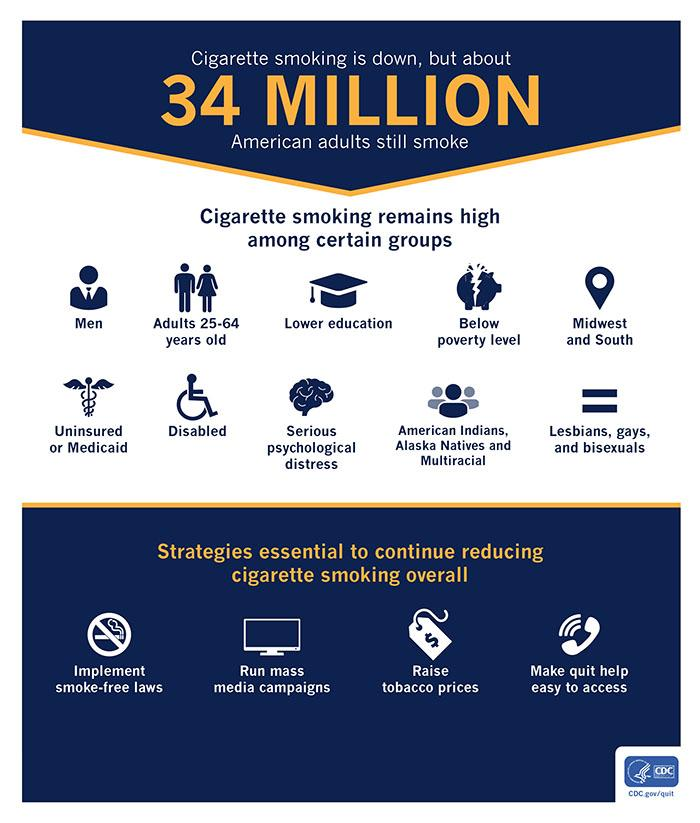Mention a couple of crucial points in this snapshot. It is essential to reduce overall cigarette smoking through the use of mass media campaigns. The American population involved in smoking of cigarettes is approximately 34 million. Smoking continues to be prevalent among adults aged 25-64 years in the United States, according to recent data. It is essential to reduce overall cigarette smoking through the implementation of smoke-free laws to promote public health and safety. In the Midwest and South regions of America, cigarette smoking remains prevalent. 